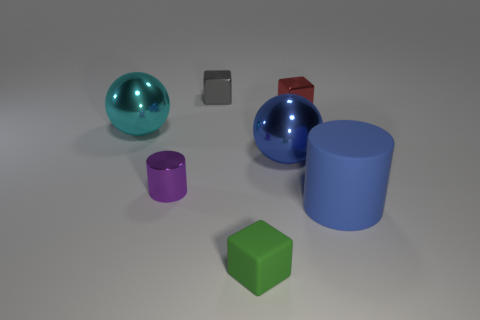What is the material of the large thing that is the same color as the matte cylinder?
Ensure brevity in your answer.  Metal. Are there any cylinders made of the same material as the large cyan sphere?
Your answer should be compact. Yes. There is a ball that is left of the green matte thing; is it the same size as the tiny red metal thing?
Offer a very short reply. No. There is a tiny cube in front of the large metal ball right of the tiny gray shiny cube; are there any big cyan things on the right side of it?
Provide a short and direct response. No. How many rubber objects are either cyan objects or big blue balls?
Your answer should be very brief. 0. What number of other objects are there of the same shape as the purple metallic object?
Your answer should be very brief. 1. Are there more small yellow shiny cylinders than small shiny blocks?
Give a very brief answer. No. There is a sphere to the right of the tiny shiny thing that is left of the small gray shiny thing that is left of the matte block; how big is it?
Give a very brief answer. Large. How big is the shiny sphere that is on the left side of the gray cube?
Your answer should be very brief. Large. What number of objects are either big rubber cylinders or large things that are behind the big blue metallic object?
Make the answer very short. 2. 